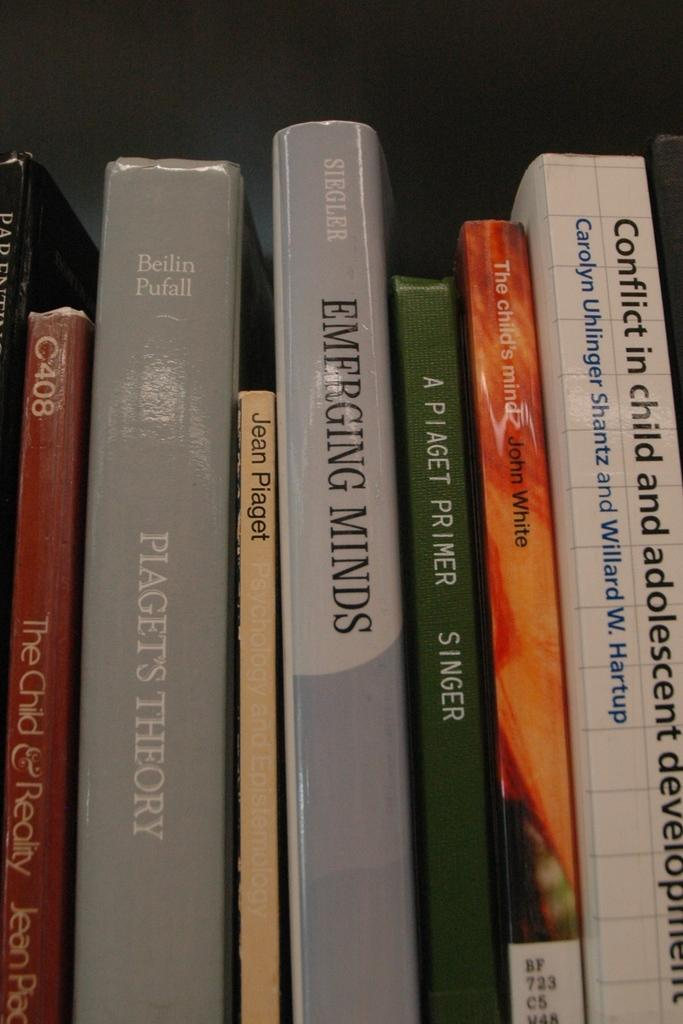<image>
Provide a brief description of the given image. Some psychology books on a library shelf including "Emerging Minds" 